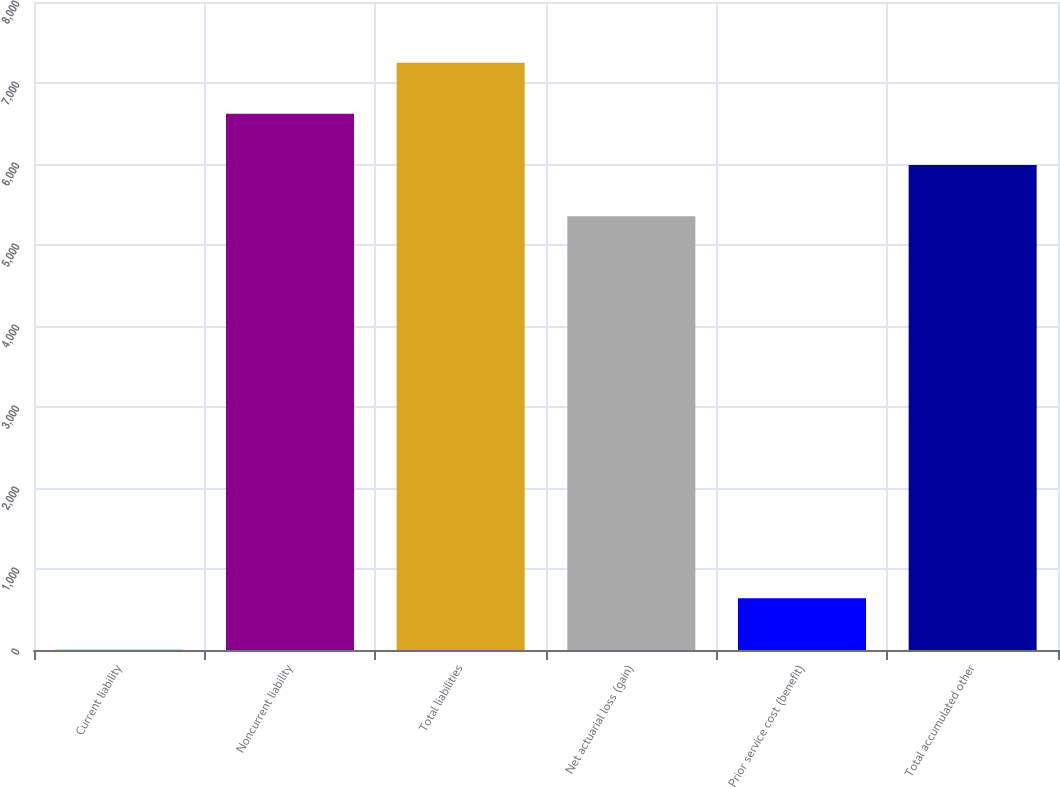<chart> <loc_0><loc_0><loc_500><loc_500><bar_chart><fcel>Current liability<fcel>Noncurrent liability<fcel>Total liabilities<fcel>Net actuarial loss (gain)<fcel>Prior service cost (benefit)<fcel>Total accumulated other<nl><fcel>7<fcel>6619.6<fcel>7251.4<fcel>5356<fcel>638.8<fcel>5987.8<nl></chart> 